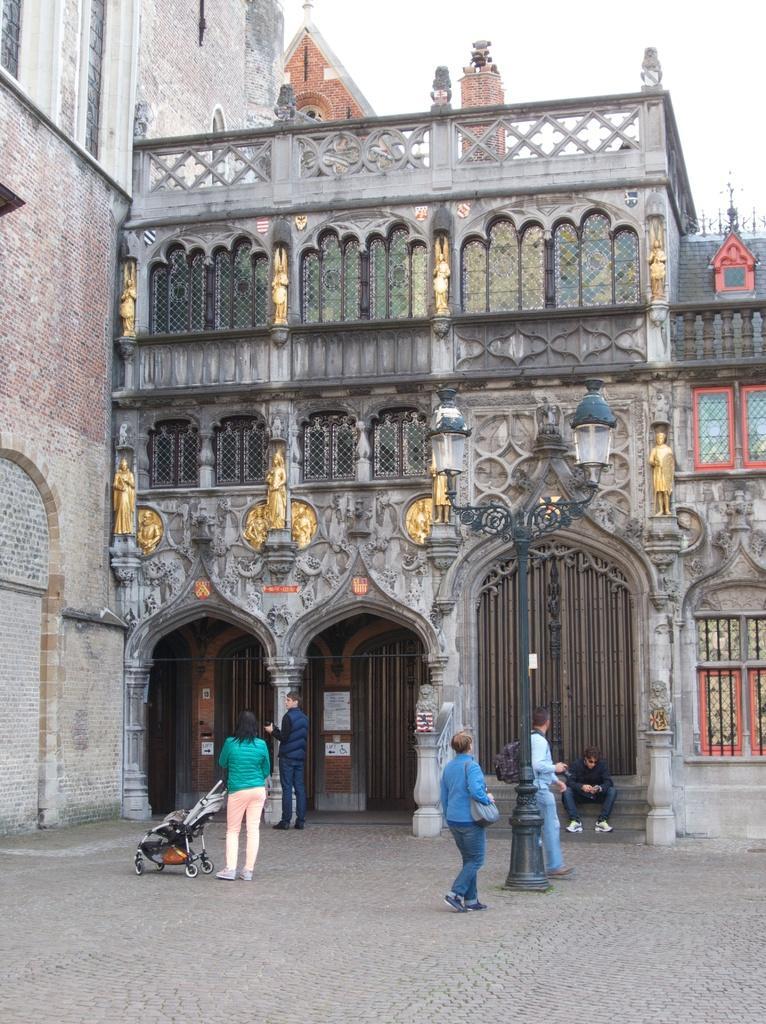In one or two sentences, can you explain what this image depicts? In this image I can see some people. In the background, I can see the building. 